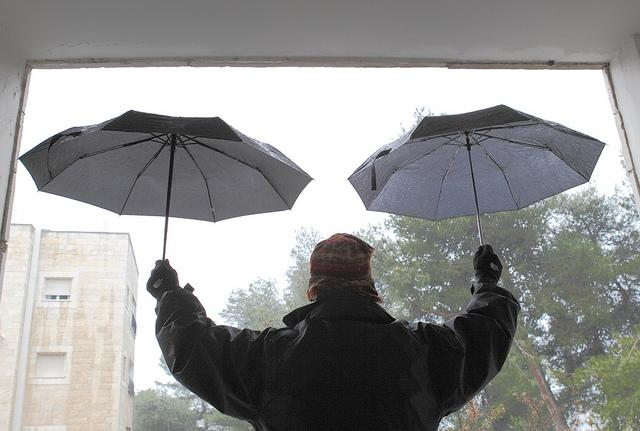Why does the man hold 2 umbrellas? Please explain your reasoning. photograph pose. No sun nor shine protection is needed in this scene.  the confidence he shows indicates a lack of confusion. 